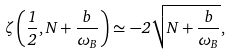Convert formula to latex. <formula><loc_0><loc_0><loc_500><loc_500>\zeta \left ( \frac { 1 } { 2 } , N + \frac { b } { \omega _ { B } } \right ) \simeq - 2 \sqrt { N + \frac { b } { \omega _ { B } } } ,</formula> 